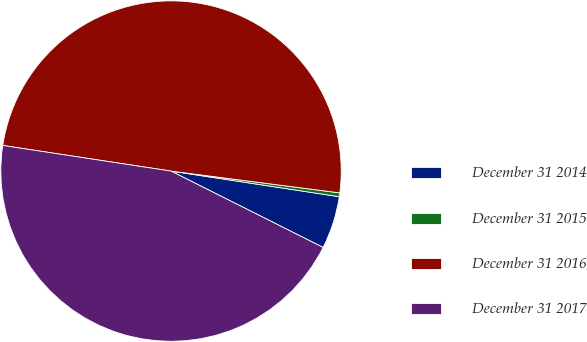<chart> <loc_0><loc_0><loc_500><loc_500><pie_chart><fcel>December 31 2014<fcel>December 31 2015<fcel>December 31 2016<fcel>December 31 2017<nl><fcel>5.0%<fcel>0.36%<fcel>49.64%<fcel>45.0%<nl></chart> 